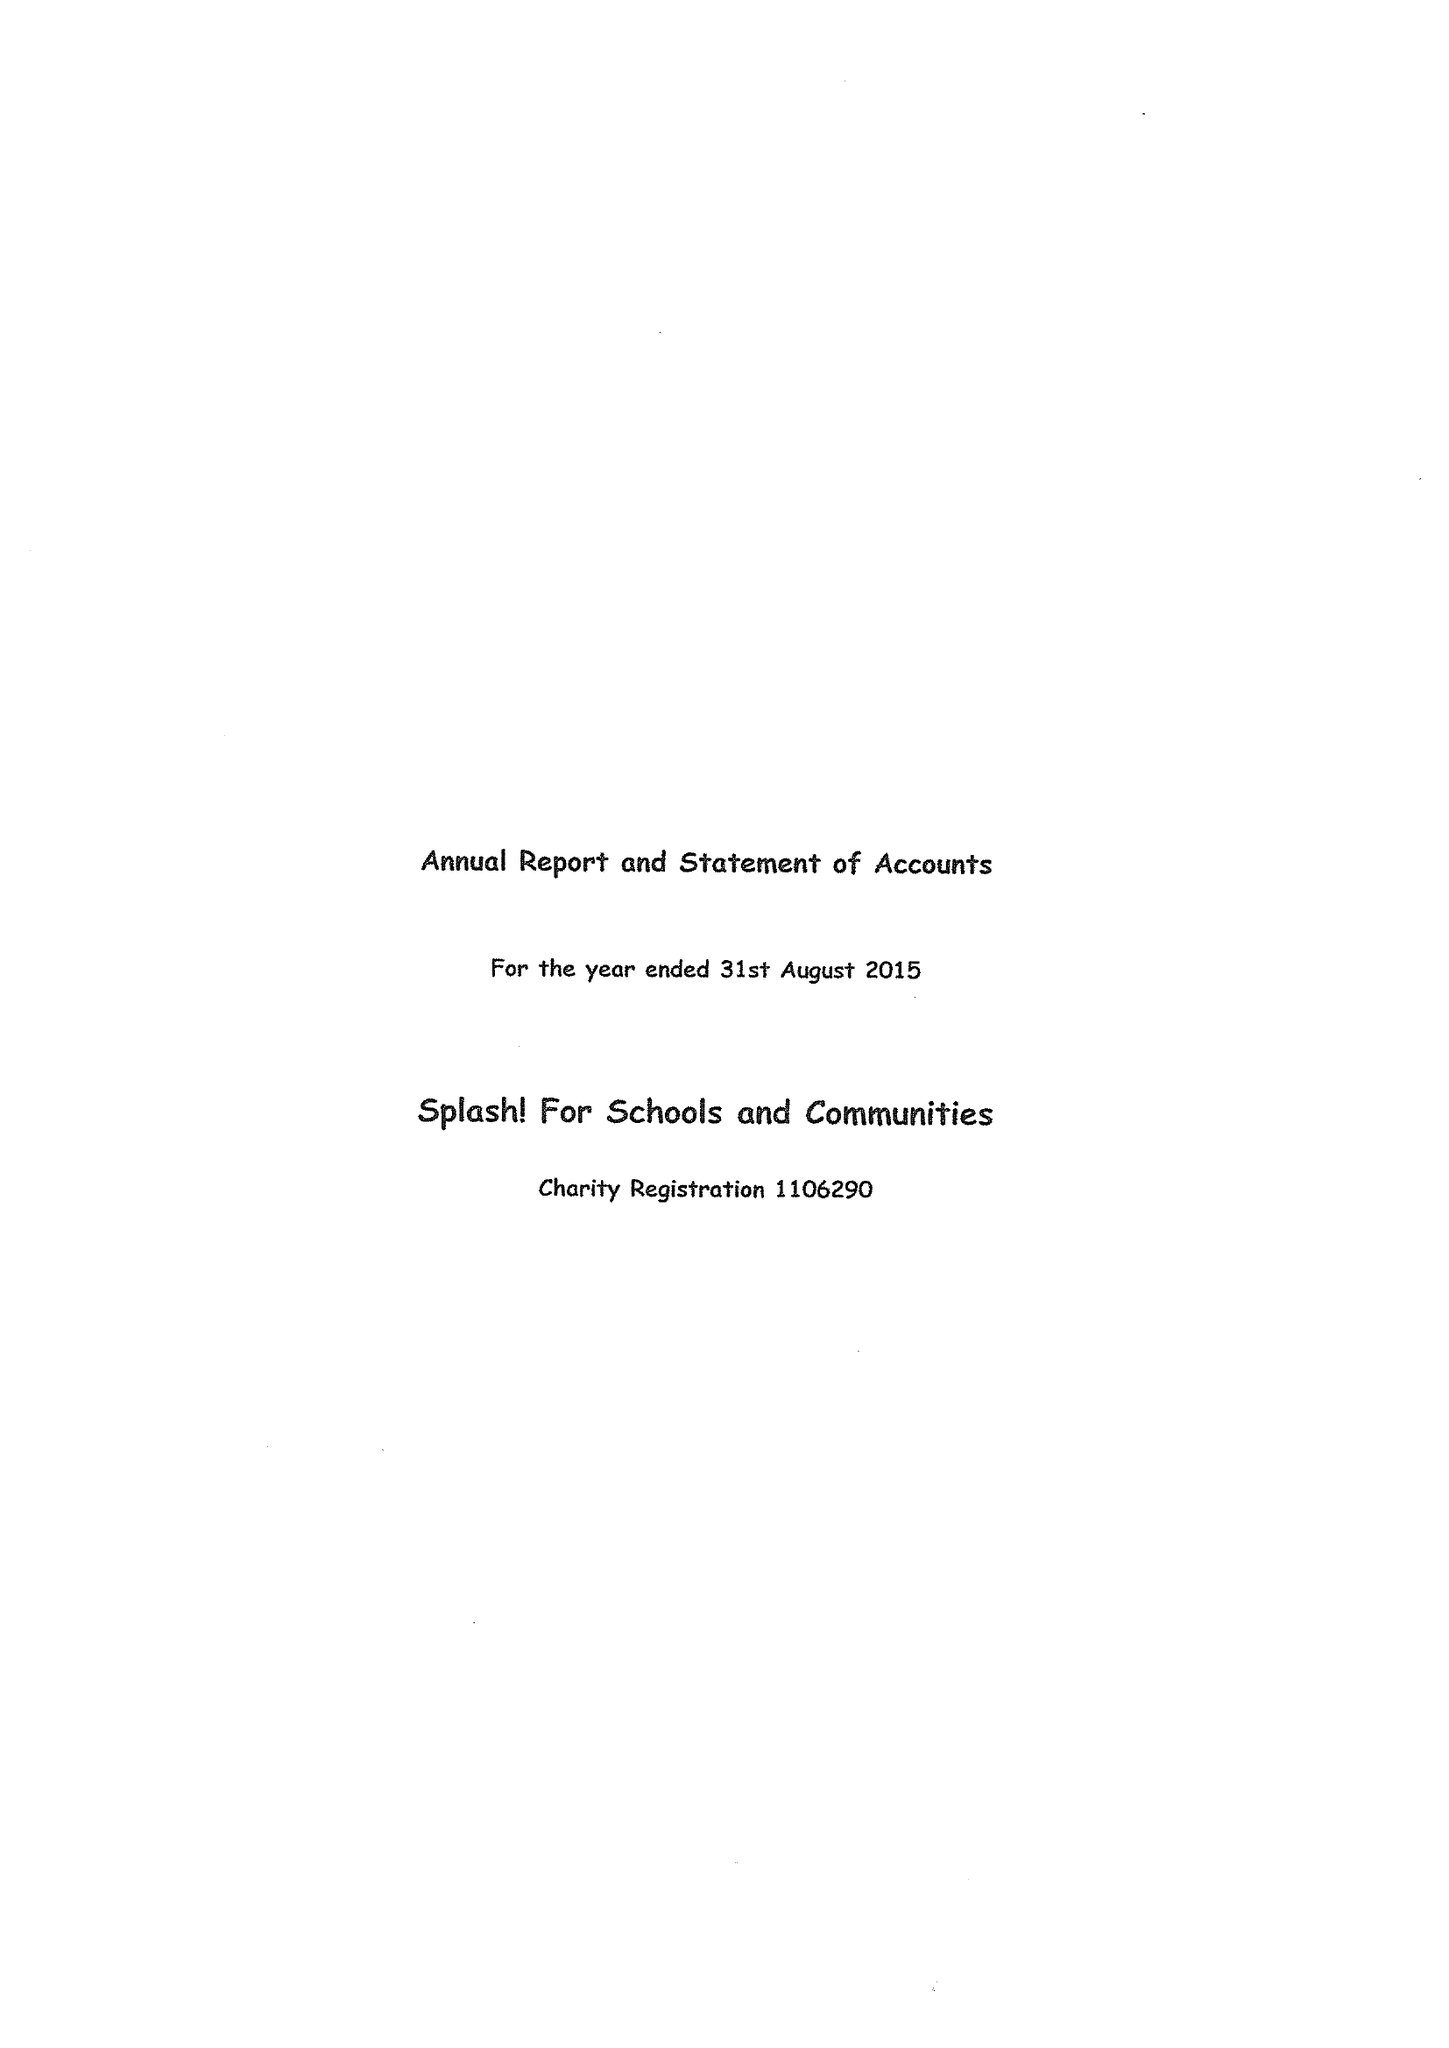What is the value for the charity_number?
Answer the question using a single word or phrase. 1106290 